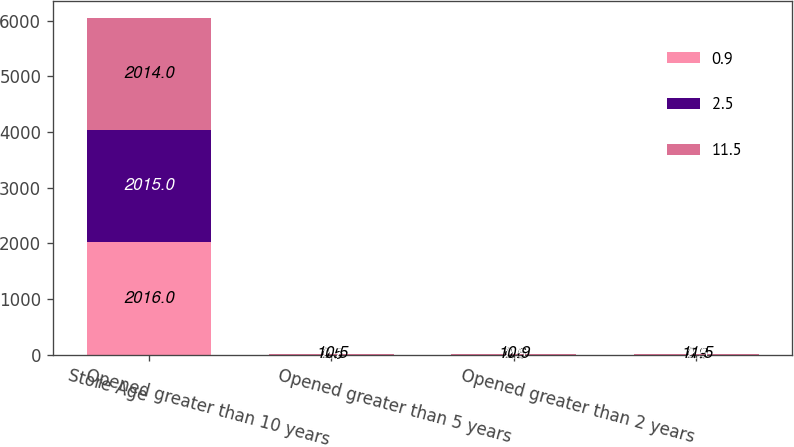<chart> <loc_0><loc_0><loc_500><loc_500><stacked_bar_chart><ecel><fcel>Store Age<fcel>Opened greater than 10 years<fcel>Opened greater than 5 years<fcel>Opened greater than 2 years<nl><fcel>0.9<fcel>2016<fcel>0.5<fcel>0.6<fcel>0.9<nl><fcel>2.5<fcel>2015<fcel>2.7<fcel>2.5<fcel>2.5<nl><fcel>11.5<fcel>2014<fcel>10.5<fcel>10.9<fcel>11.5<nl></chart> 